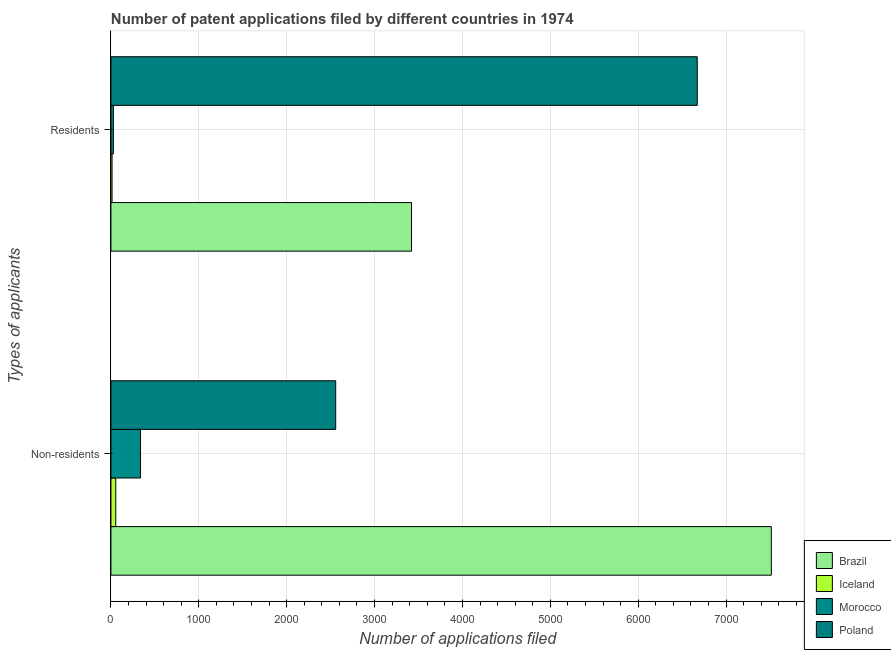Are the number of bars per tick equal to the number of legend labels?
Provide a short and direct response. Yes. Are the number of bars on each tick of the Y-axis equal?
Your answer should be compact. Yes. How many bars are there on the 1st tick from the bottom?
Offer a terse response. 4. What is the label of the 1st group of bars from the top?
Give a very brief answer. Residents. What is the number of patent applications by non residents in Brazil?
Your answer should be very brief. 7515. Across all countries, what is the maximum number of patent applications by residents?
Make the answer very short. 6672. Across all countries, what is the minimum number of patent applications by non residents?
Make the answer very short. 55. In which country was the number of patent applications by residents maximum?
Offer a very short reply. Poland. In which country was the number of patent applications by non residents minimum?
Give a very brief answer. Iceland. What is the total number of patent applications by residents in the graph?
Your response must be concise. 1.01e+04. What is the difference between the number of patent applications by residents in Morocco and that in Iceland?
Ensure brevity in your answer.  15. What is the difference between the number of patent applications by residents in Morocco and the number of patent applications by non residents in Brazil?
Provide a short and direct response. -7487. What is the average number of patent applications by residents per country?
Offer a terse response. 2533.5. What is the difference between the number of patent applications by residents and number of patent applications by non residents in Iceland?
Keep it short and to the point. -42. What is the ratio of the number of patent applications by non residents in Morocco to that in Brazil?
Give a very brief answer. 0.04. In how many countries, is the number of patent applications by residents greater than the average number of patent applications by residents taken over all countries?
Offer a terse response. 2. What does the 3rd bar from the top in Residents represents?
Ensure brevity in your answer.  Iceland. What is the difference between two consecutive major ticks on the X-axis?
Make the answer very short. 1000. Are the values on the major ticks of X-axis written in scientific E-notation?
Your answer should be compact. No. How many legend labels are there?
Provide a succinct answer. 4. What is the title of the graph?
Provide a succinct answer. Number of patent applications filed by different countries in 1974. Does "Niger" appear as one of the legend labels in the graph?
Your response must be concise. No. What is the label or title of the X-axis?
Give a very brief answer. Number of applications filed. What is the label or title of the Y-axis?
Make the answer very short. Types of applicants. What is the Number of applications filed of Brazil in Non-residents?
Offer a terse response. 7515. What is the Number of applications filed of Iceland in Non-residents?
Your answer should be very brief. 55. What is the Number of applications filed of Morocco in Non-residents?
Your response must be concise. 337. What is the Number of applications filed of Poland in Non-residents?
Your answer should be very brief. 2558. What is the Number of applications filed of Brazil in Residents?
Your response must be concise. 3421. What is the Number of applications filed of Poland in Residents?
Provide a short and direct response. 6672. Across all Types of applicants, what is the maximum Number of applications filed in Brazil?
Give a very brief answer. 7515. Across all Types of applicants, what is the maximum Number of applications filed of Morocco?
Offer a very short reply. 337. Across all Types of applicants, what is the maximum Number of applications filed of Poland?
Keep it short and to the point. 6672. Across all Types of applicants, what is the minimum Number of applications filed of Brazil?
Offer a terse response. 3421. Across all Types of applicants, what is the minimum Number of applications filed in Poland?
Your response must be concise. 2558. What is the total Number of applications filed in Brazil in the graph?
Keep it short and to the point. 1.09e+04. What is the total Number of applications filed of Morocco in the graph?
Provide a short and direct response. 365. What is the total Number of applications filed of Poland in the graph?
Offer a terse response. 9230. What is the difference between the Number of applications filed of Brazil in Non-residents and that in Residents?
Offer a terse response. 4094. What is the difference between the Number of applications filed of Iceland in Non-residents and that in Residents?
Make the answer very short. 42. What is the difference between the Number of applications filed of Morocco in Non-residents and that in Residents?
Offer a very short reply. 309. What is the difference between the Number of applications filed in Poland in Non-residents and that in Residents?
Your answer should be very brief. -4114. What is the difference between the Number of applications filed of Brazil in Non-residents and the Number of applications filed of Iceland in Residents?
Offer a very short reply. 7502. What is the difference between the Number of applications filed in Brazil in Non-residents and the Number of applications filed in Morocco in Residents?
Keep it short and to the point. 7487. What is the difference between the Number of applications filed of Brazil in Non-residents and the Number of applications filed of Poland in Residents?
Ensure brevity in your answer.  843. What is the difference between the Number of applications filed in Iceland in Non-residents and the Number of applications filed in Poland in Residents?
Your answer should be compact. -6617. What is the difference between the Number of applications filed of Morocco in Non-residents and the Number of applications filed of Poland in Residents?
Make the answer very short. -6335. What is the average Number of applications filed in Brazil per Types of applicants?
Keep it short and to the point. 5468. What is the average Number of applications filed of Iceland per Types of applicants?
Make the answer very short. 34. What is the average Number of applications filed in Morocco per Types of applicants?
Offer a very short reply. 182.5. What is the average Number of applications filed in Poland per Types of applicants?
Your answer should be very brief. 4615. What is the difference between the Number of applications filed of Brazil and Number of applications filed of Iceland in Non-residents?
Give a very brief answer. 7460. What is the difference between the Number of applications filed in Brazil and Number of applications filed in Morocco in Non-residents?
Keep it short and to the point. 7178. What is the difference between the Number of applications filed of Brazil and Number of applications filed of Poland in Non-residents?
Make the answer very short. 4957. What is the difference between the Number of applications filed of Iceland and Number of applications filed of Morocco in Non-residents?
Make the answer very short. -282. What is the difference between the Number of applications filed in Iceland and Number of applications filed in Poland in Non-residents?
Offer a very short reply. -2503. What is the difference between the Number of applications filed of Morocco and Number of applications filed of Poland in Non-residents?
Keep it short and to the point. -2221. What is the difference between the Number of applications filed of Brazil and Number of applications filed of Iceland in Residents?
Your response must be concise. 3408. What is the difference between the Number of applications filed of Brazil and Number of applications filed of Morocco in Residents?
Your response must be concise. 3393. What is the difference between the Number of applications filed of Brazil and Number of applications filed of Poland in Residents?
Provide a succinct answer. -3251. What is the difference between the Number of applications filed of Iceland and Number of applications filed of Poland in Residents?
Make the answer very short. -6659. What is the difference between the Number of applications filed of Morocco and Number of applications filed of Poland in Residents?
Provide a succinct answer. -6644. What is the ratio of the Number of applications filed of Brazil in Non-residents to that in Residents?
Keep it short and to the point. 2.2. What is the ratio of the Number of applications filed in Iceland in Non-residents to that in Residents?
Make the answer very short. 4.23. What is the ratio of the Number of applications filed in Morocco in Non-residents to that in Residents?
Offer a terse response. 12.04. What is the ratio of the Number of applications filed in Poland in Non-residents to that in Residents?
Keep it short and to the point. 0.38. What is the difference between the highest and the second highest Number of applications filed of Brazil?
Provide a succinct answer. 4094. What is the difference between the highest and the second highest Number of applications filed of Iceland?
Provide a succinct answer. 42. What is the difference between the highest and the second highest Number of applications filed of Morocco?
Your answer should be compact. 309. What is the difference between the highest and the second highest Number of applications filed in Poland?
Give a very brief answer. 4114. What is the difference between the highest and the lowest Number of applications filed in Brazil?
Provide a short and direct response. 4094. What is the difference between the highest and the lowest Number of applications filed in Morocco?
Offer a very short reply. 309. What is the difference between the highest and the lowest Number of applications filed of Poland?
Provide a succinct answer. 4114. 